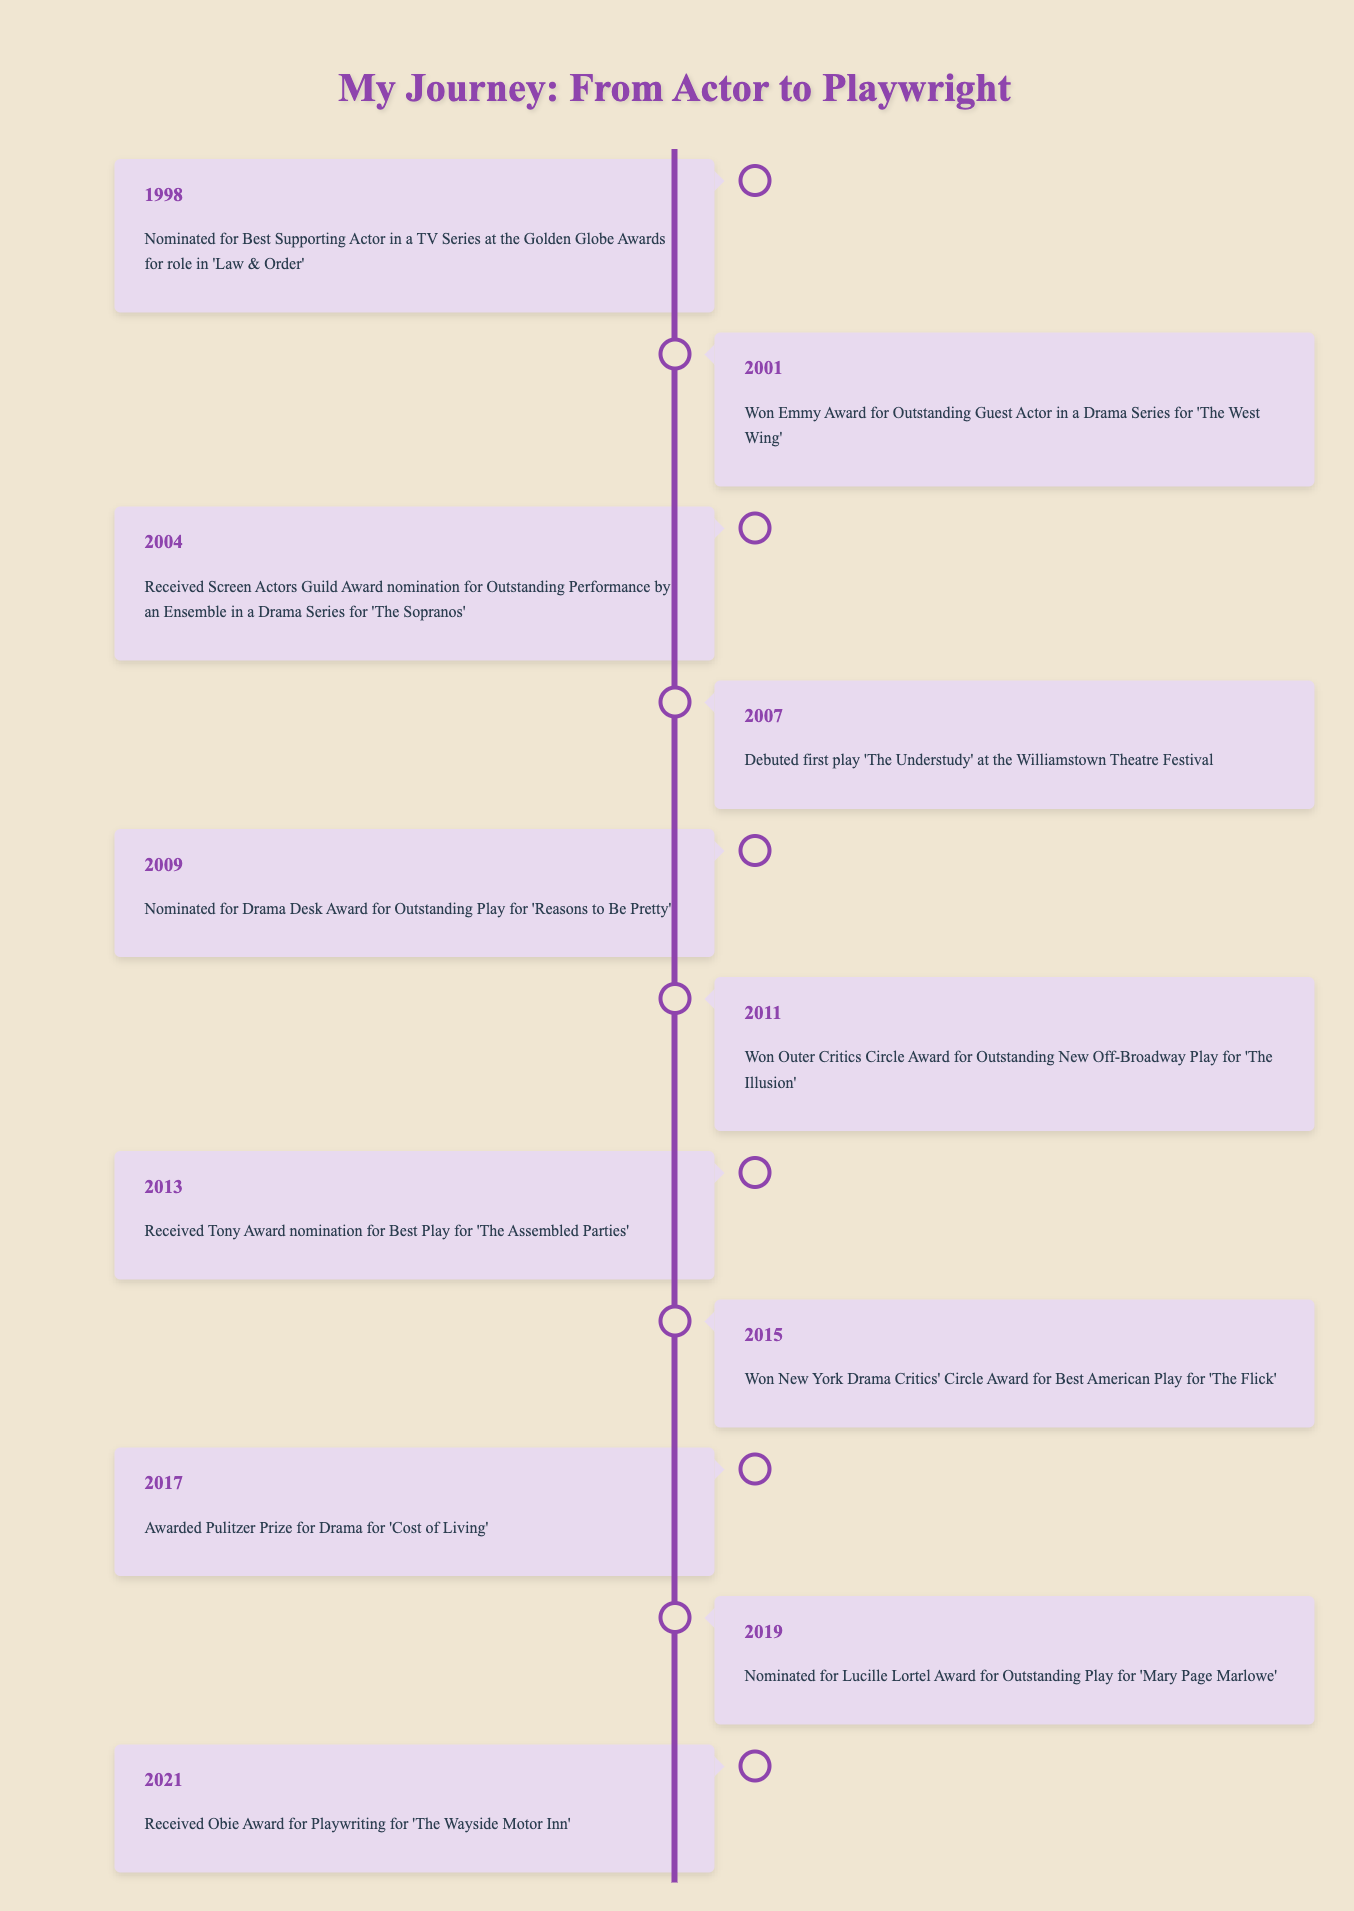What award did you win in 2001? In 2001, you won the Emmy Award for Outstanding Guest Actor in a Drama Series for 'The West Wing'.
Answer: Emmy Award for Outstanding Guest Actor How many years between your first play debut and the Pulitzer Prize win? Your first play debuted in 2007 and you won the Pulitzer Prize in 2017. The difference is 2017 - 2007 = 10 years.
Answer: 10 years Did you receive any nominations for your plays before winning the Pulitzer Prize? You received nominations for 'Reasons to Be Pretty' in 2009 and for 'The Assembled Parties' in 2013 before winning the Pulitzer Prize in 2017. Yes, you received nominations.
Answer: Yes Which event occurred in 2013? In 2013, you received the Tony Award nomination for Best Play for 'The Assembled Parties'.
Answer: Tony Award nomination for 'The Assembled Parties' What is the total number of awards won by 2021? You won the Emmy Award in 2001, the Outer Critics Circle Award in 2011, the New York Drama Critics' Circle Award in 2015, and the Pulitzer Prize in 2017, totaling 4 awards won.
Answer: 4 awards Was 'The Flick' the only play for which you won the New York Drama Critics' Circle Award? The timeline only mentions one instance of winning the New York Drama Critics' Circle Award for 'The Flick' in 2015, indicating that it is the only mentioned win for this award. Yes, that was the only one listed.
Answer: Yes In how many years did you receive awards compared to nominations? You won awards in 2001, 2011, 2015, and 2017 (4 wins), compared to 1998, 2004, 2009, 2013, 2019, and 2021 for nominations (6 nominations). The comparison shows 4 wins to 6 nominations.
Answer: 4 wins and 6 nominations What was the first event listed in the timeline? The first event is the nomination for Best Supporting Actor in a TV Series at the Golden Globe Awards for the role in 'Law & Order' in 1998.
Answer: Nominated for Golden Globe in 1998 Which play received a Drama Desk Award nomination? The play 'Reasons to Be Pretty' received a Drama Desk Award nomination in 2009 for Outstanding Play.
Answer: 'Reasons to Be Pretty' 